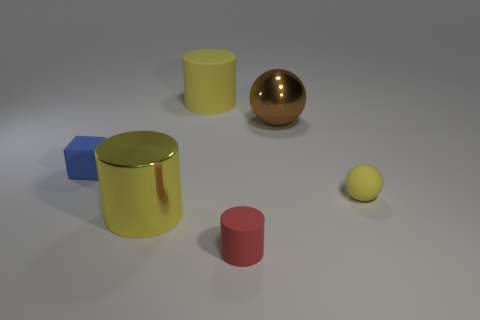Which object stands out the most, and why? The golden sphere stands out the most due to its reflective, shiny surface that contrasts with the matte finishes of the other objects. Additionally, its spherical shape differs from the other cylindrical and cubical shapes in the image, making it visually distinctive. 